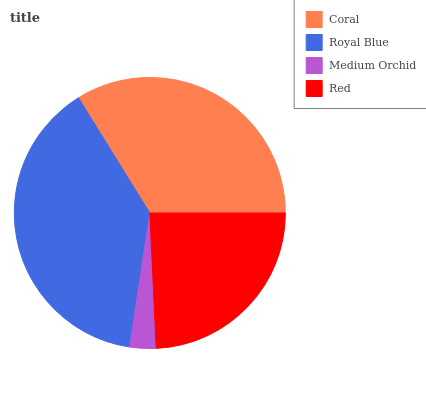Is Medium Orchid the minimum?
Answer yes or no. Yes. Is Royal Blue the maximum?
Answer yes or no. Yes. Is Royal Blue the minimum?
Answer yes or no. No. Is Medium Orchid the maximum?
Answer yes or no. No. Is Royal Blue greater than Medium Orchid?
Answer yes or no. Yes. Is Medium Orchid less than Royal Blue?
Answer yes or no. Yes. Is Medium Orchid greater than Royal Blue?
Answer yes or no. No. Is Royal Blue less than Medium Orchid?
Answer yes or no. No. Is Coral the high median?
Answer yes or no. Yes. Is Red the low median?
Answer yes or no. Yes. Is Red the high median?
Answer yes or no. No. Is Medium Orchid the low median?
Answer yes or no. No. 